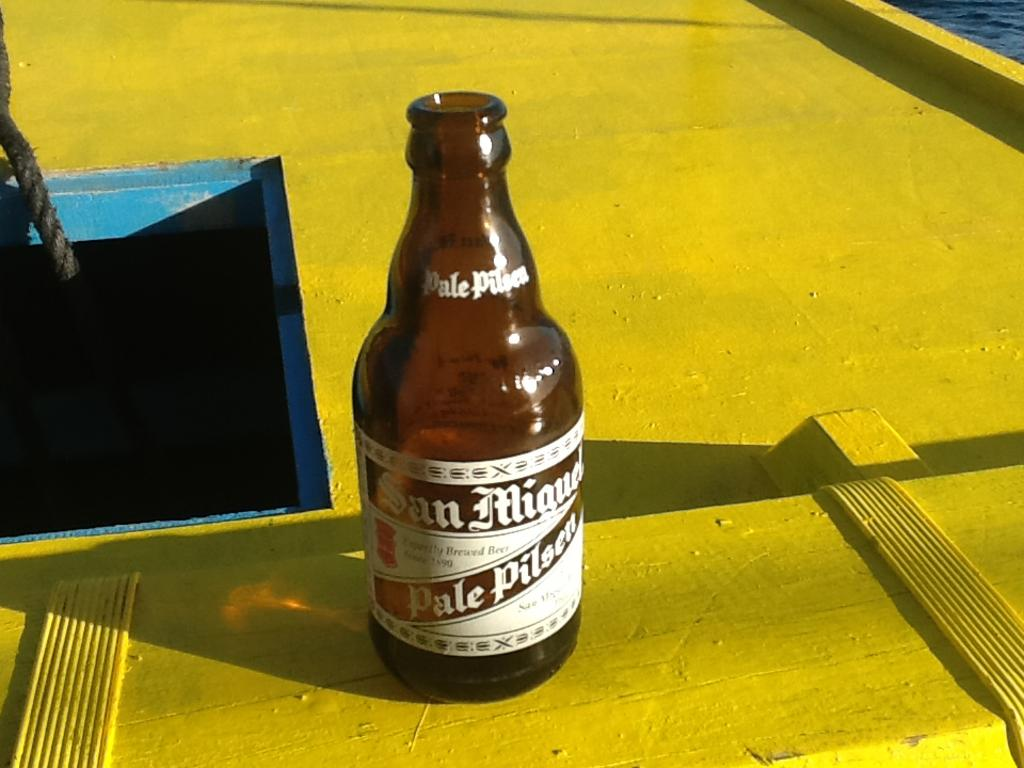<image>
Present a compact description of the photo's key features. A bottle of Pale Pilsen has a white label. 